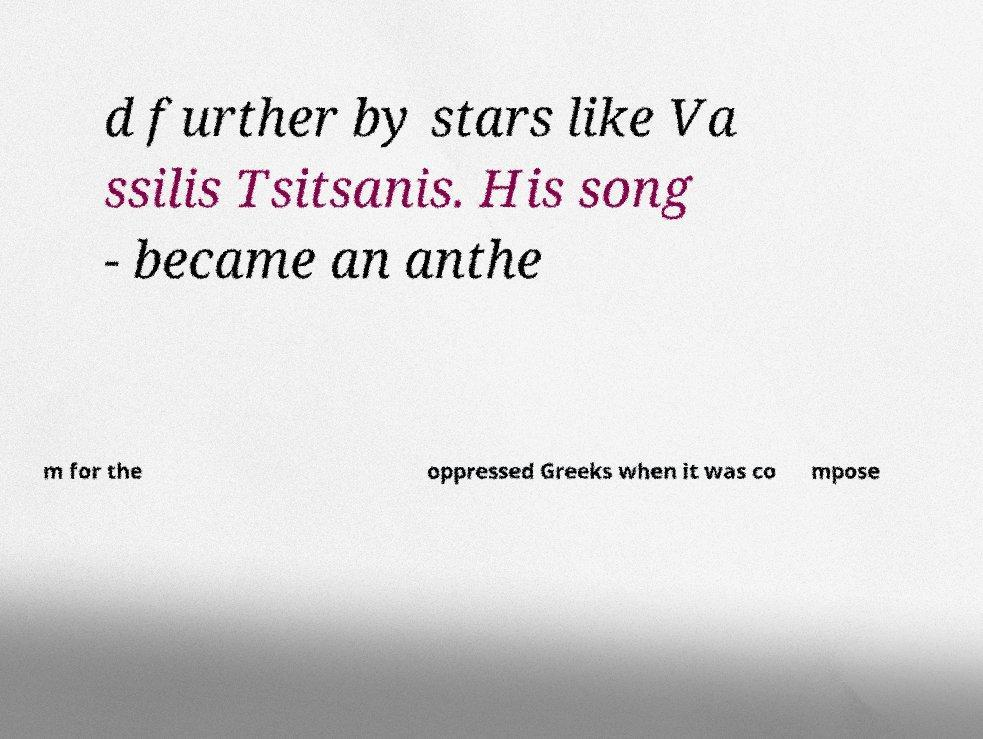Please read and relay the text visible in this image. What does it say? d further by stars like Va ssilis Tsitsanis. His song - became an anthe m for the oppressed Greeks when it was co mpose 